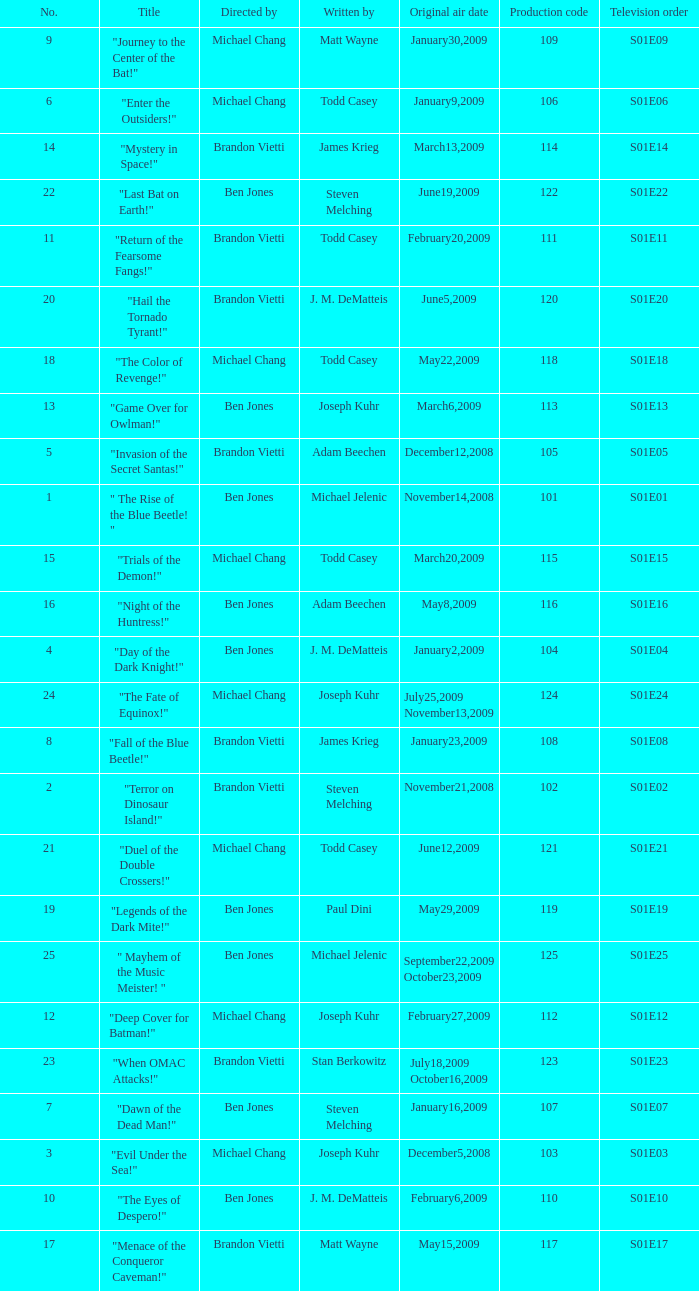What is the the television order of "deep cover for batman!" S01E12. 